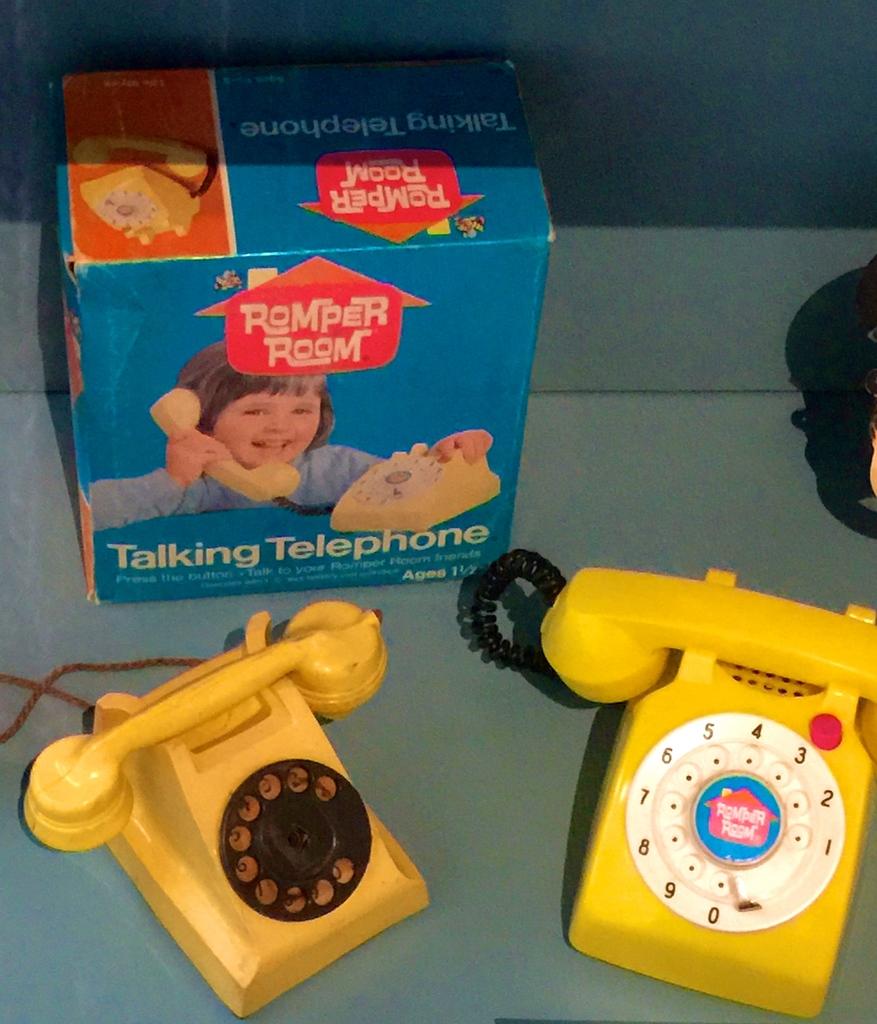What is the name of this toy?
Make the answer very short. Talking telephone. What is the age for the kids?
Your answer should be very brief. 1 1/2. 